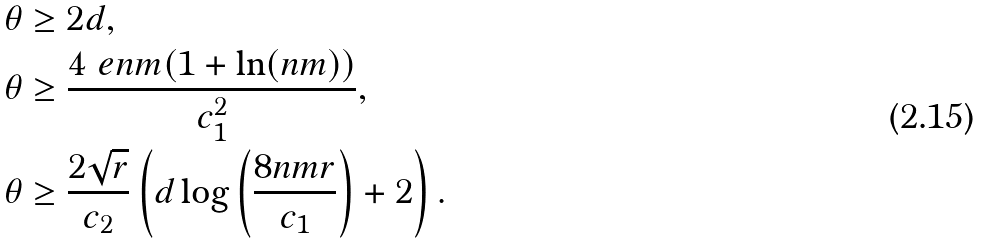<formula> <loc_0><loc_0><loc_500><loc_500>\theta & \geq 2 d , \\ \theta & \geq \frac { 4 \ e n m ( 1 + \ln ( n m ) ) } { c _ { 1 } ^ { 2 } } , \\ \theta & \geq \frac { 2 \sqrt { r } } { c _ { 2 } } \left ( d \log \left ( \frac { 8 n m r } { c _ { 1 } } \right ) + 2 \right ) .</formula> 